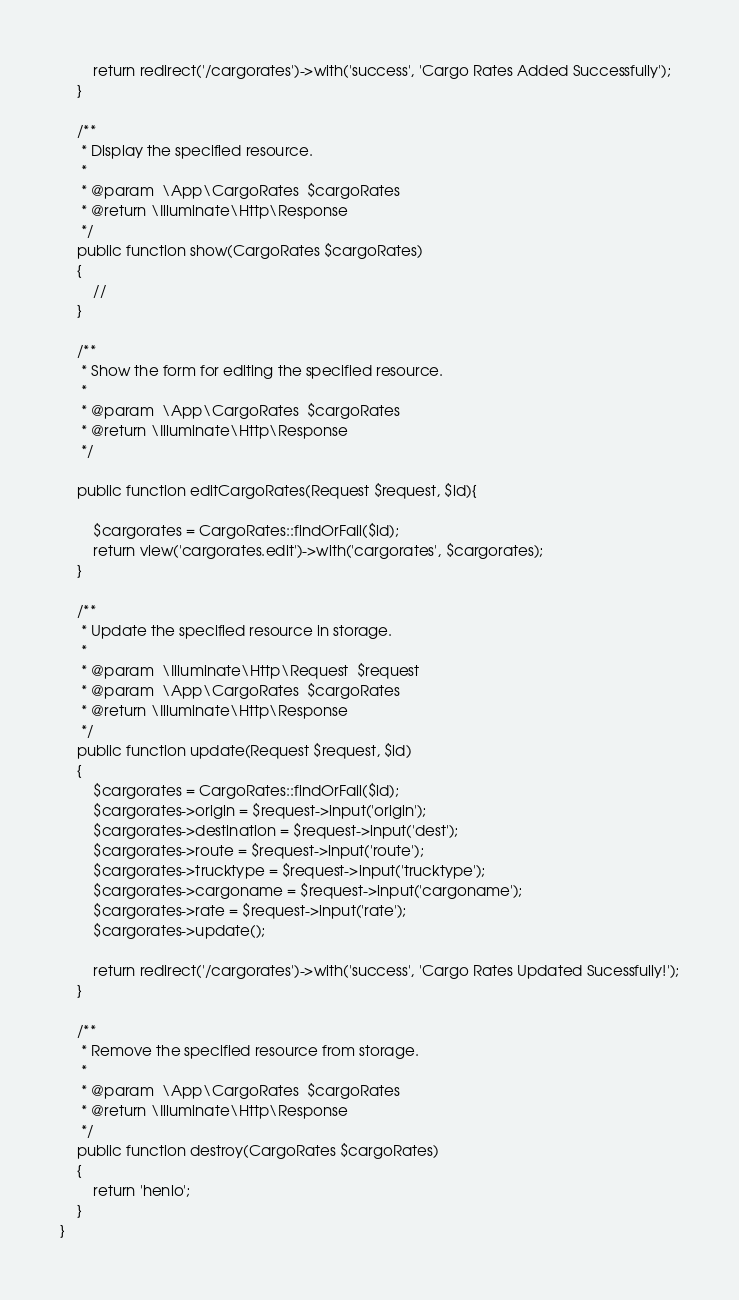Convert code to text. <code><loc_0><loc_0><loc_500><loc_500><_PHP_>        return redirect('/cargorates')->with('success', 'Cargo Rates Added Successfully');
    }

    /**
     * Display the specified resource.
     *
     * @param  \App\CargoRates  $cargoRates
     * @return \Illuminate\Http\Response
     */
    public function show(CargoRates $cargoRates)
    {
        //
    }

    /**
     * Show the form for editing the specified resource.
     *
     * @param  \App\CargoRates  $cargoRates
     * @return \Illuminate\Http\Response
     */

    public function editCargoRates(Request $request, $id){
    
        $cargorates = CargoRates::findOrFail($id);
        return view('cargorates.edit')->with('cargorates', $cargorates);
    }

    /**
     * Update the specified resource in storage.
     *
     * @param  \Illuminate\Http\Request  $request
     * @param  \App\CargoRates  $cargoRates
     * @return \Illuminate\Http\Response
     */
    public function update(Request $request, $id)
    {
        $cargorates = CargoRates::findOrFail($id);
        $cargorates->origin = $request->input('origin');
        $cargorates->destination = $request->input('dest');
        $cargorates->route = $request->input('route');
        $cargorates->trucktype = $request->input('trucktype');   
        $cargorates->cargoname = $request->input('cargoname');   
        $cargorates->rate = $request->input('rate');   
        $cargorates->update();
        
        return redirect('/cargorates')->with('success', 'Cargo Rates Updated Sucessfully!');
    }

    /**
     * Remove the specified resource from storage.
     *
     * @param  \App\CargoRates  $cargoRates
     * @return \Illuminate\Http\Response
     */
    public function destroy(CargoRates $cargoRates)
    {
        return 'henlo';
    }
}
</code> 